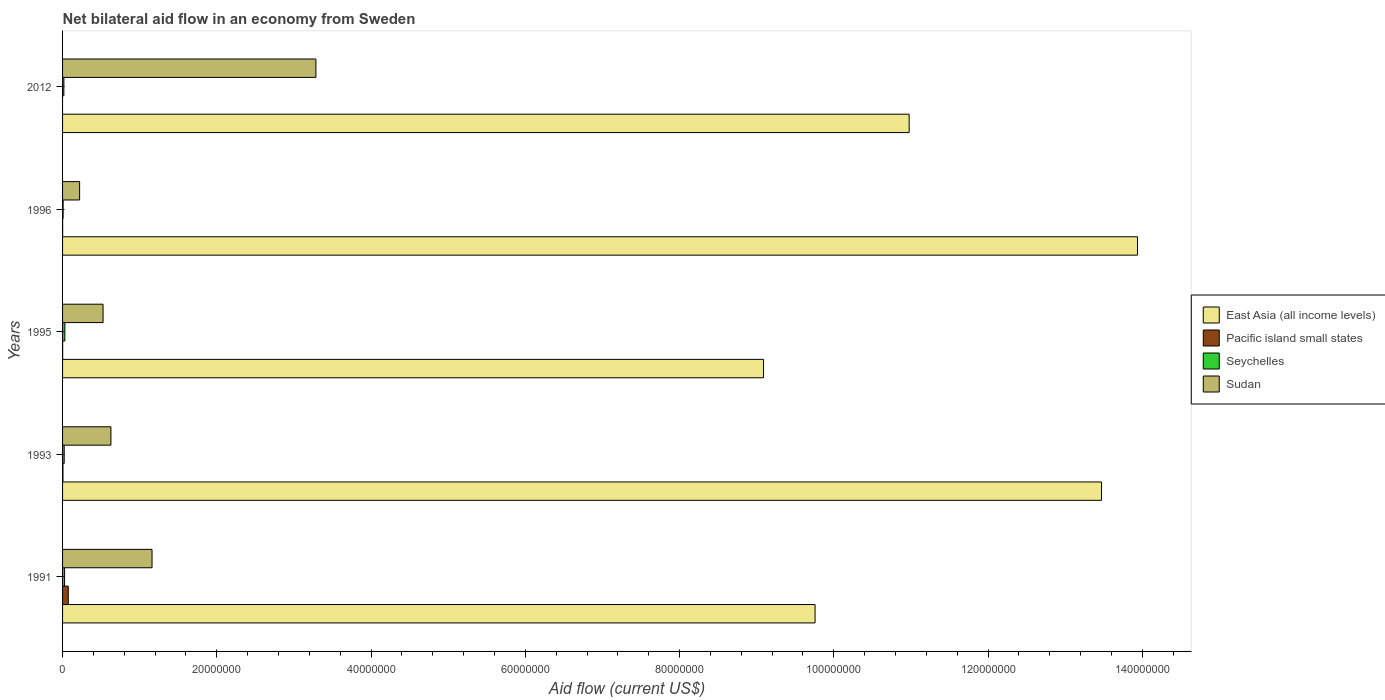How many different coloured bars are there?
Your answer should be very brief. 4. How many groups of bars are there?
Offer a very short reply. 5. Are the number of bars per tick equal to the number of legend labels?
Your response must be concise. No. Are the number of bars on each tick of the Y-axis equal?
Offer a terse response. No. How many bars are there on the 5th tick from the top?
Offer a very short reply. 4. In how many cases, is the number of bars for a given year not equal to the number of legend labels?
Offer a terse response. 1. What is the net bilateral aid flow in East Asia (all income levels) in 1995?
Keep it short and to the point. 9.09e+07. Across all years, what is the maximum net bilateral aid flow in East Asia (all income levels)?
Provide a succinct answer. 1.39e+08. Across all years, what is the minimum net bilateral aid flow in Seychelles?
Give a very brief answer. 7.00e+04. In which year was the net bilateral aid flow in Seychelles maximum?
Offer a very short reply. 1995. What is the total net bilateral aid flow in Seychelles in the graph?
Ensure brevity in your answer.  1.01e+06. What is the difference between the net bilateral aid flow in East Asia (all income levels) in 1996 and that in 2012?
Provide a short and direct response. 2.96e+07. What is the difference between the net bilateral aid flow in Pacific island small states in 1996 and the net bilateral aid flow in East Asia (all income levels) in 1995?
Offer a very short reply. -9.09e+07. What is the average net bilateral aid flow in Seychelles per year?
Make the answer very short. 2.02e+05. In the year 1993, what is the difference between the net bilateral aid flow in Seychelles and net bilateral aid flow in Sudan?
Offer a very short reply. -6.06e+06. In how many years, is the net bilateral aid flow in East Asia (all income levels) greater than 8000000 US$?
Your response must be concise. 5. Is the net bilateral aid flow in Seychelles in 1993 less than that in 1995?
Your answer should be very brief. Yes. What is the difference between the highest and the second highest net bilateral aid flow in Seychelles?
Keep it short and to the point. 4.00e+04. In how many years, is the net bilateral aid flow in Seychelles greater than the average net bilateral aid flow in Seychelles taken over all years?
Give a very brief answer. 3. Is the sum of the net bilateral aid flow in East Asia (all income levels) in 1993 and 1996 greater than the maximum net bilateral aid flow in Sudan across all years?
Ensure brevity in your answer.  Yes. Is it the case that in every year, the sum of the net bilateral aid flow in East Asia (all income levels) and net bilateral aid flow in Sudan is greater than the net bilateral aid flow in Seychelles?
Ensure brevity in your answer.  Yes. How many years are there in the graph?
Your answer should be compact. 5. What is the difference between two consecutive major ticks on the X-axis?
Offer a terse response. 2.00e+07. Where does the legend appear in the graph?
Your answer should be very brief. Center right. How are the legend labels stacked?
Make the answer very short. Vertical. What is the title of the graph?
Give a very brief answer. Net bilateral aid flow in an economy from Sweden. What is the Aid flow (current US$) in East Asia (all income levels) in 1991?
Your response must be concise. 9.76e+07. What is the Aid flow (current US$) of Pacific island small states in 1991?
Provide a succinct answer. 7.40e+05. What is the Aid flow (current US$) in Sudan in 1991?
Your response must be concise. 1.16e+07. What is the Aid flow (current US$) in East Asia (all income levels) in 1993?
Give a very brief answer. 1.35e+08. What is the Aid flow (current US$) of Pacific island small states in 1993?
Keep it short and to the point. 5.00e+04. What is the Aid flow (current US$) of Seychelles in 1993?
Make the answer very short. 2.10e+05. What is the Aid flow (current US$) in Sudan in 1993?
Your answer should be very brief. 6.27e+06. What is the Aid flow (current US$) of East Asia (all income levels) in 1995?
Ensure brevity in your answer.  9.09e+07. What is the Aid flow (current US$) in Pacific island small states in 1995?
Keep it short and to the point. 10000. What is the Aid flow (current US$) in Sudan in 1995?
Give a very brief answer. 5.25e+06. What is the Aid flow (current US$) in East Asia (all income levels) in 1996?
Provide a short and direct response. 1.39e+08. What is the Aid flow (current US$) in Pacific island small states in 1996?
Your answer should be compact. 10000. What is the Aid flow (current US$) of Sudan in 1996?
Offer a terse response. 2.21e+06. What is the Aid flow (current US$) of East Asia (all income levels) in 2012?
Your answer should be very brief. 1.10e+08. What is the Aid flow (current US$) in Pacific island small states in 2012?
Provide a succinct answer. 0. What is the Aid flow (current US$) in Sudan in 2012?
Keep it short and to the point. 3.28e+07. Across all years, what is the maximum Aid flow (current US$) of East Asia (all income levels)?
Offer a very short reply. 1.39e+08. Across all years, what is the maximum Aid flow (current US$) in Pacific island small states?
Provide a succinct answer. 7.40e+05. Across all years, what is the maximum Aid flow (current US$) in Sudan?
Give a very brief answer. 3.28e+07. Across all years, what is the minimum Aid flow (current US$) in East Asia (all income levels)?
Offer a very short reply. 9.09e+07. Across all years, what is the minimum Aid flow (current US$) of Pacific island small states?
Your answer should be very brief. 0. Across all years, what is the minimum Aid flow (current US$) in Seychelles?
Offer a terse response. 7.00e+04. Across all years, what is the minimum Aid flow (current US$) in Sudan?
Your response must be concise. 2.21e+06. What is the total Aid flow (current US$) in East Asia (all income levels) in the graph?
Provide a succinct answer. 5.72e+08. What is the total Aid flow (current US$) in Pacific island small states in the graph?
Provide a succinct answer. 8.10e+05. What is the total Aid flow (current US$) in Seychelles in the graph?
Keep it short and to the point. 1.01e+06. What is the total Aid flow (current US$) in Sudan in the graph?
Your answer should be compact. 5.82e+07. What is the difference between the Aid flow (current US$) of East Asia (all income levels) in 1991 and that in 1993?
Keep it short and to the point. -3.71e+07. What is the difference between the Aid flow (current US$) of Pacific island small states in 1991 and that in 1993?
Ensure brevity in your answer.  6.90e+05. What is the difference between the Aid flow (current US$) of Seychelles in 1991 and that in 1993?
Your answer should be compact. 5.00e+04. What is the difference between the Aid flow (current US$) of Sudan in 1991 and that in 1993?
Offer a terse response. 5.33e+06. What is the difference between the Aid flow (current US$) of East Asia (all income levels) in 1991 and that in 1995?
Your answer should be compact. 6.68e+06. What is the difference between the Aid flow (current US$) in Pacific island small states in 1991 and that in 1995?
Your answer should be compact. 7.30e+05. What is the difference between the Aid flow (current US$) of Sudan in 1991 and that in 1995?
Provide a succinct answer. 6.35e+06. What is the difference between the Aid flow (current US$) of East Asia (all income levels) in 1991 and that in 1996?
Offer a very short reply. -4.18e+07. What is the difference between the Aid flow (current US$) in Pacific island small states in 1991 and that in 1996?
Make the answer very short. 7.30e+05. What is the difference between the Aid flow (current US$) of Sudan in 1991 and that in 1996?
Keep it short and to the point. 9.39e+06. What is the difference between the Aid flow (current US$) in East Asia (all income levels) in 1991 and that in 2012?
Your answer should be very brief. -1.22e+07. What is the difference between the Aid flow (current US$) of Sudan in 1991 and that in 2012?
Make the answer very short. -2.12e+07. What is the difference between the Aid flow (current US$) of East Asia (all income levels) in 1993 and that in 1995?
Provide a succinct answer. 4.38e+07. What is the difference between the Aid flow (current US$) of Pacific island small states in 1993 and that in 1995?
Offer a terse response. 4.00e+04. What is the difference between the Aid flow (current US$) in Sudan in 1993 and that in 1995?
Ensure brevity in your answer.  1.02e+06. What is the difference between the Aid flow (current US$) of East Asia (all income levels) in 1993 and that in 1996?
Make the answer very short. -4.67e+06. What is the difference between the Aid flow (current US$) in Pacific island small states in 1993 and that in 1996?
Make the answer very short. 4.00e+04. What is the difference between the Aid flow (current US$) in Seychelles in 1993 and that in 1996?
Make the answer very short. 1.40e+05. What is the difference between the Aid flow (current US$) in Sudan in 1993 and that in 1996?
Provide a short and direct response. 4.06e+06. What is the difference between the Aid flow (current US$) in East Asia (all income levels) in 1993 and that in 2012?
Keep it short and to the point. 2.49e+07. What is the difference between the Aid flow (current US$) in Sudan in 1993 and that in 2012?
Your answer should be very brief. -2.66e+07. What is the difference between the Aid flow (current US$) in East Asia (all income levels) in 1995 and that in 1996?
Give a very brief answer. -4.85e+07. What is the difference between the Aid flow (current US$) of Seychelles in 1995 and that in 1996?
Make the answer very short. 2.30e+05. What is the difference between the Aid flow (current US$) in Sudan in 1995 and that in 1996?
Provide a short and direct response. 3.04e+06. What is the difference between the Aid flow (current US$) in East Asia (all income levels) in 1995 and that in 2012?
Provide a succinct answer. -1.89e+07. What is the difference between the Aid flow (current US$) of Seychelles in 1995 and that in 2012?
Give a very brief answer. 1.30e+05. What is the difference between the Aid flow (current US$) in Sudan in 1995 and that in 2012?
Ensure brevity in your answer.  -2.76e+07. What is the difference between the Aid flow (current US$) of East Asia (all income levels) in 1996 and that in 2012?
Offer a very short reply. 2.96e+07. What is the difference between the Aid flow (current US$) of Seychelles in 1996 and that in 2012?
Offer a very short reply. -1.00e+05. What is the difference between the Aid flow (current US$) in Sudan in 1996 and that in 2012?
Your answer should be compact. -3.06e+07. What is the difference between the Aid flow (current US$) of East Asia (all income levels) in 1991 and the Aid flow (current US$) of Pacific island small states in 1993?
Give a very brief answer. 9.75e+07. What is the difference between the Aid flow (current US$) of East Asia (all income levels) in 1991 and the Aid flow (current US$) of Seychelles in 1993?
Your response must be concise. 9.74e+07. What is the difference between the Aid flow (current US$) of East Asia (all income levels) in 1991 and the Aid flow (current US$) of Sudan in 1993?
Provide a short and direct response. 9.13e+07. What is the difference between the Aid flow (current US$) in Pacific island small states in 1991 and the Aid flow (current US$) in Seychelles in 1993?
Your answer should be compact. 5.30e+05. What is the difference between the Aid flow (current US$) of Pacific island small states in 1991 and the Aid flow (current US$) of Sudan in 1993?
Give a very brief answer. -5.53e+06. What is the difference between the Aid flow (current US$) of Seychelles in 1991 and the Aid flow (current US$) of Sudan in 1993?
Your answer should be very brief. -6.01e+06. What is the difference between the Aid flow (current US$) in East Asia (all income levels) in 1991 and the Aid flow (current US$) in Pacific island small states in 1995?
Offer a terse response. 9.76e+07. What is the difference between the Aid flow (current US$) in East Asia (all income levels) in 1991 and the Aid flow (current US$) in Seychelles in 1995?
Your response must be concise. 9.73e+07. What is the difference between the Aid flow (current US$) of East Asia (all income levels) in 1991 and the Aid flow (current US$) of Sudan in 1995?
Provide a succinct answer. 9.23e+07. What is the difference between the Aid flow (current US$) in Pacific island small states in 1991 and the Aid flow (current US$) in Seychelles in 1995?
Your answer should be very brief. 4.40e+05. What is the difference between the Aid flow (current US$) in Pacific island small states in 1991 and the Aid flow (current US$) in Sudan in 1995?
Offer a very short reply. -4.51e+06. What is the difference between the Aid flow (current US$) of Seychelles in 1991 and the Aid flow (current US$) of Sudan in 1995?
Your answer should be very brief. -4.99e+06. What is the difference between the Aid flow (current US$) in East Asia (all income levels) in 1991 and the Aid flow (current US$) in Pacific island small states in 1996?
Provide a succinct answer. 9.76e+07. What is the difference between the Aid flow (current US$) in East Asia (all income levels) in 1991 and the Aid flow (current US$) in Seychelles in 1996?
Offer a terse response. 9.75e+07. What is the difference between the Aid flow (current US$) of East Asia (all income levels) in 1991 and the Aid flow (current US$) of Sudan in 1996?
Keep it short and to the point. 9.54e+07. What is the difference between the Aid flow (current US$) in Pacific island small states in 1991 and the Aid flow (current US$) in Seychelles in 1996?
Make the answer very short. 6.70e+05. What is the difference between the Aid flow (current US$) of Pacific island small states in 1991 and the Aid flow (current US$) of Sudan in 1996?
Offer a terse response. -1.47e+06. What is the difference between the Aid flow (current US$) in Seychelles in 1991 and the Aid flow (current US$) in Sudan in 1996?
Your response must be concise. -1.95e+06. What is the difference between the Aid flow (current US$) of East Asia (all income levels) in 1991 and the Aid flow (current US$) of Seychelles in 2012?
Give a very brief answer. 9.74e+07. What is the difference between the Aid flow (current US$) of East Asia (all income levels) in 1991 and the Aid flow (current US$) of Sudan in 2012?
Your response must be concise. 6.47e+07. What is the difference between the Aid flow (current US$) in Pacific island small states in 1991 and the Aid flow (current US$) in Seychelles in 2012?
Offer a terse response. 5.70e+05. What is the difference between the Aid flow (current US$) in Pacific island small states in 1991 and the Aid flow (current US$) in Sudan in 2012?
Offer a very short reply. -3.21e+07. What is the difference between the Aid flow (current US$) of Seychelles in 1991 and the Aid flow (current US$) of Sudan in 2012?
Give a very brief answer. -3.26e+07. What is the difference between the Aid flow (current US$) in East Asia (all income levels) in 1993 and the Aid flow (current US$) in Pacific island small states in 1995?
Make the answer very short. 1.35e+08. What is the difference between the Aid flow (current US$) in East Asia (all income levels) in 1993 and the Aid flow (current US$) in Seychelles in 1995?
Make the answer very short. 1.34e+08. What is the difference between the Aid flow (current US$) in East Asia (all income levels) in 1993 and the Aid flow (current US$) in Sudan in 1995?
Your response must be concise. 1.29e+08. What is the difference between the Aid flow (current US$) of Pacific island small states in 1993 and the Aid flow (current US$) of Seychelles in 1995?
Give a very brief answer. -2.50e+05. What is the difference between the Aid flow (current US$) of Pacific island small states in 1993 and the Aid flow (current US$) of Sudan in 1995?
Offer a terse response. -5.20e+06. What is the difference between the Aid flow (current US$) of Seychelles in 1993 and the Aid flow (current US$) of Sudan in 1995?
Ensure brevity in your answer.  -5.04e+06. What is the difference between the Aid flow (current US$) in East Asia (all income levels) in 1993 and the Aid flow (current US$) in Pacific island small states in 1996?
Ensure brevity in your answer.  1.35e+08. What is the difference between the Aid flow (current US$) of East Asia (all income levels) in 1993 and the Aid flow (current US$) of Seychelles in 1996?
Ensure brevity in your answer.  1.35e+08. What is the difference between the Aid flow (current US$) in East Asia (all income levels) in 1993 and the Aid flow (current US$) in Sudan in 1996?
Your answer should be compact. 1.32e+08. What is the difference between the Aid flow (current US$) of Pacific island small states in 1993 and the Aid flow (current US$) of Sudan in 1996?
Provide a short and direct response. -2.16e+06. What is the difference between the Aid flow (current US$) of East Asia (all income levels) in 1993 and the Aid flow (current US$) of Seychelles in 2012?
Your answer should be compact. 1.35e+08. What is the difference between the Aid flow (current US$) of East Asia (all income levels) in 1993 and the Aid flow (current US$) of Sudan in 2012?
Keep it short and to the point. 1.02e+08. What is the difference between the Aid flow (current US$) of Pacific island small states in 1993 and the Aid flow (current US$) of Sudan in 2012?
Your answer should be compact. -3.28e+07. What is the difference between the Aid flow (current US$) in Seychelles in 1993 and the Aid flow (current US$) in Sudan in 2012?
Offer a terse response. -3.26e+07. What is the difference between the Aid flow (current US$) of East Asia (all income levels) in 1995 and the Aid flow (current US$) of Pacific island small states in 1996?
Your answer should be compact. 9.09e+07. What is the difference between the Aid flow (current US$) of East Asia (all income levels) in 1995 and the Aid flow (current US$) of Seychelles in 1996?
Offer a very short reply. 9.08e+07. What is the difference between the Aid flow (current US$) of East Asia (all income levels) in 1995 and the Aid flow (current US$) of Sudan in 1996?
Your response must be concise. 8.87e+07. What is the difference between the Aid flow (current US$) in Pacific island small states in 1995 and the Aid flow (current US$) in Sudan in 1996?
Make the answer very short. -2.20e+06. What is the difference between the Aid flow (current US$) in Seychelles in 1995 and the Aid flow (current US$) in Sudan in 1996?
Provide a short and direct response. -1.91e+06. What is the difference between the Aid flow (current US$) in East Asia (all income levels) in 1995 and the Aid flow (current US$) in Seychelles in 2012?
Your answer should be very brief. 9.07e+07. What is the difference between the Aid flow (current US$) in East Asia (all income levels) in 1995 and the Aid flow (current US$) in Sudan in 2012?
Ensure brevity in your answer.  5.80e+07. What is the difference between the Aid flow (current US$) of Pacific island small states in 1995 and the Aid flow (current US$) of Seychelles in 2012?
Ensure brevity in your answer.  -1.60e+05. What is the difference between the Aid flow (current US$) of Pacific island small states in 1995 and the Aid flow (current US$) of Sudan in 2012?
Make the answer very short. -3.28e+07. What is the difference between the Aid flow (current US$) in Seychelles in 1995 and the Aid flow (current US$) in Sudan in 2012?
Provide a succinct answer. -3.26e+07. What is the difference between the Aid flow (current US$) in East Asia (all income levels) in 1996 and the Aid flow (current US$) in Seychelles in 2012?
Keep it short and to the point. 1.39e+08. What is the difference between the Aid flow (current US$) of East Asia (all income levels) in 1996 and the Aid flow (current US$) of Sudan in 2012?
Provide a succinct answer. 1.07e+08. What is the difference between the Aid flow (current US$) in Pacific island small states in 1996 and the Aid flow (current US$) in Seychelles in 2012?
Your response must be concise. -1.60e+05. What is the difference between the Aid flow (current US$) in Pacific island small states in 1996 and the Aid flow (current US$) in Sudan in 2012?
Make the answer very short. -3.28e+07. What is the difference between the Aid flow (current US$) of Seychelles in 1996 and the Aid flow (current US$) of Sudan in 2012?
Your answer should be very brief. -3.28e+07. What is the average Aid flow (current US$) in East Asia (all income levels) per year?
Offer a terse response. 1.14e+08. What is the average Aid flow (current US$) of Pacific island small states per year?
Provide a short and direct response. 1.62e+05. What is the average Aid flow (current US$) of Seychelles per year?
Offer a terse response. 2.02e+05. What is the average Aid flow (current US$) in Sudan per year?
Give a very brief answer. 1.16e+07. In the year 1991, what is the difference between the Aid flow (current US$) of East Asia (all income levels) and Aid flow (current US$) of Pacific island small states?
Give a very brief answer. 9.68e+07. In the year 1991, what is the difference between the Aid flow (current US$) of East Asia (all income levels) and Aid flow (current US$) of Seychelles?
Give a very brief answer. 9.73e+07. In the year 1991, what is the difference between the Aid flow (current US$) in East Asia (all income levels) and Aid flow (current US$) in Sudan?
Your answer should be very brief. 8.60e+07. In the year 1991, what is the difference between the Aid flow (current US$) of Pacific island small states and Aid flow (current US$) of Seychelles?
Provide a short and direct response. 4.80e+05. In the year 1991, what is the difference between the Aid flow (current US$) of Pacific island small states and Aid flow (current US$) of Sudan?
Offer a very short reply. -1.09e+07. In the year 1991, what is the difference between the Aid flow (current US$) of Seychelles and Aid flow (current US$) of Sudan?
Offer a very short reply. -1.13e+07. In the year 1993, what is the difference between the Aid flow (current US$) of East Asia (all income levels) and Aid flow (current US$) of Pacific island small states?
Ensure brevity in your answer.  1.35e+08. In the year 1993, what is the difference between the Aid flow (current US$) in East Asia (all income levels) and Aid flow (current US$) in Seychelles?
Your answer should be very brief. 1.34e+08. In the year 1993, what is the difference between the Aid flow (current US$) of East Asia (all income levels) and Aid flow (current US$) of Sudan?
Your response must be concise. 1.28e+08. In the year 1993, what is the difference between the Aid flow (current US$) of Pacific island small states and Aid flow (current US$) of Seychelles?
Give a very brief answer. -1.60e+05. In the year 1993, what is the difference between the Aid flow (current US$) of Pacific island small states and Aid flow (current US$) of Sudan?
Make the answer very short. -6.22e+06. In the year 1993, what is the difference between the Aid flow (current US$) in Seychelles and Aid flow (current US$) in Sudan?
Offer a terse response. -6.06e+06. In the year 1995, what is the difference between the Aid flow (current US$) of East Asia (all income levels) and Aid flow (current US$) of Pacific island small states?
Provide a short and direct response. 9.09e+07. In the year 1995, what is the difference between the Aid flow (current US$) in East Asia (all income levels) and Aid flow (current US$) in Seychelles?
Offer a very short reply. 9.06e+07. In the year 1995, what is the difference between the Aid flow (current US$) in East Asia (all income levels) and Aid flow (current US$) in Sudan?
Ensure brevity in your answer.  8.56e+07. In the year 1995, what is the difference between the Aid flow (current US$) of Pacific island small states and Aid flow (current US$) of Sudan?
Offer a very short reply. -5.24e+06. In the year 1995, what is the difference between the Aid flow (current US$) in Seychelles and Aid flow (current US$) in Sudan?
Give a very brief answer. -4.95e+06. In the year 1996, what is the difference between the Aid flow (current US$) of East Asia (all income levels) and Aid flow (current US$) of Pacific island small states?
Offer a terse response. 1.39e+08. In the year 1996, what is the difference between the Aid flow (current US$) of East Asia (all income levels) and Aid flow (current US$) of Seychelles?
Ensure brevity in your answer.  1.39e+08. In the year 1996, what is the difference between the Aid flow (current US$) of East Asia (all income levels) and Aid flow (current US$) of Sudan?
Provide a succinct answer. 1.37e+08. In the year 1996, what is the difference between the Aid flow (current US$) of Pacific island small states and Aid flow (current US$) of Sudan?
Your response must be concise. -2.20e+06. In the year 1996, what is the difference between the Aid flow (current US$) in Seychelles and Aid flow (current US$) in Sudan?
Make the answer very short. -2.14e+06. In the year 2012, what is the difference between the Aid flow (current US$) in East Asia (all income levels) and Aid flow (current US$) in Seychelles?
Provide a succinct answer. 1.10e+08. In the year 2012, what is the difference between the Aid flow (current US$) in East Asia (all income levels) and Aid flow (current US$) in Sudan?
Offer a very short reply. 7.69e+07. In the year 2012, what is the difference between the Aid flow (current US$) in Seychelles and Aid flow (current US$) in Sudan?
Provide a succinct answer. -3.27e+07. What is the ratio of the Aid flow (current US$) of East Asia (all income levels) in 1991 to that in 1993?
Your answer should be compact. 0.72. What is the ratio of the Aid flow (current US$) in Seychelles in 1991 to that in 1993?
Give a very brief answer. 1.24. What is the ratio of the Aid flow (current US$) in Sudan in 1991 to that in 1993?
Make the answer very short. 1.85. What is the ratio of the Aid flow (current US$) in East Asia (all income levels) in 1991 to that in 1995?
Ensure brevity in your answer.  1.07. What is the ratio of the Aid flow (current US$) of Seychelles in 1991 to that in 1995?
Your answer should be very brief. 0.87. What is the ratio of the Aid flow (current US$) in Sudan in 1991 to that in 1995?
Provide a succinct answer. 2.21. What is the ratio of the Aid flow (current US$) of Seychelles in 1991 to that in 1996?
Make the answer very short. 3.71. What is the ratio of the Aid flow (current US$) in Sudan in 1991 to that in 1996?
Your answer should be very brief. 5.25. What is the ratio of the Aid flow (current US$) in Seychelles in 1991 to that in 2012?
Give a very brief answer. 1.53. What is the ratio of the Aid flow (current US$) in Sudan in 1991 to that in 2012?
Ensure brevity in your answer.  0.35. What is the ratio of the Aid flow (current US$) in East Asia (all income levels) in 1993 to that in 1995?
Give a very brief answer. 1.48. What is the ratio of the Aid flow (current US$) of Sudan in 1993 to that in 1995?
Give a very brief answer. 1.19. What is the ratio of the Aid flow (current US$) of East Asia (all income levels) in 1993 to that in 1996?
Provide a short and direct response. 0.97. What is the ratio of the Aid flow (current US$) of Sudan in 1993 to that in 1996?
Provide a short and direct response. 2.84. What is the ratio of the Aid flow (current US$) in East Asia (all income levels) in 1993 to that in 2012?
Offer a very short reply. 1.23. What is the ratio of the Aid flow (current US$) in Seychelles in 1993 to that in 2012?
Your answer should be very brief. 1.24. What is the ratio of the Aid flow (current US$) of Sudan in 1993 to that in 2012?
Offer a terse response. 0.19. What is the ratio of the Aid flow (current US$) of East Asia (all income levels) in 1995 to that in 1996?
Offer a terse response. 0.65. What is the ratio of the Aid flow (current US$) in Seychelles in 1995 to that in 1996?
Make the answer very short. 4.29. What is the ratio of the Aid flow (current US$) of Sudan in 1995 to that in 1996?
Your answer should be compact. 2.38. What is the ratio of the Aid flow (current US$) in East Asia (all income levels) in 1995 to that in 2012?
Offer a very short reply. 0.83. What is the ratio of the Aid flow (current US$) in Seychelles in 1995 to that in 2012?
Provide a short and direct response. 1.76. What is the ratio of the Aid flow (current US$) in Sudan in 1995 to that in 2012?
Provide a succinct answer. 0.16. What is the ratio of the Aid flow (current US$) in East Asia (all income levels) in 1996 to that in 2012?
Your answer should be very brief. 1.27. What is the ratio of the Aid flow (current US$) of Seychelles in 1996 to that in 2012?
Your answer should be very brief. 0.41. What is the ratio of the Aid flow (current US$) of Sudan in 1996 to that in 2012?
Keep it short and to the point. 0.07. What is the difference between the highest and the second highest Aid flow (current US$) in East Asia (all income levels)?
Your response must be concise. 4.67e+06. What is the difference between the highest and the second highest Aid flow (current US$) in Pacific island small states?
Provide a succinct answer. 6.90e+05. What is the difference between the highest and the second highest Aid flow (current US$) in Seychelles?
Offer a terse response. 4.00e+04. What is the difference between the highest and the second highest Aid flow (current US$) in Sudan?
Offer a terse response. 2.12e+07. What is the difference between the highest and the lowest Aid flow (current US$) of East Asia (all income levels)?
Offer a very short reply. 4.85e+07. What is the difference between the highest and the lowest Aid flow (current US$) in Pacific island small states?
Your answer should be compact. 7.40e+05. What is the difference between the highest and the lowest Aid flow (current US$) in Seychelles?
Give a very brief answer. 2.30e+05. What is the difference between the highest and the lowest Aid flow (current US$) of Sudan?
Your response must be concise. 3.06e+07. 